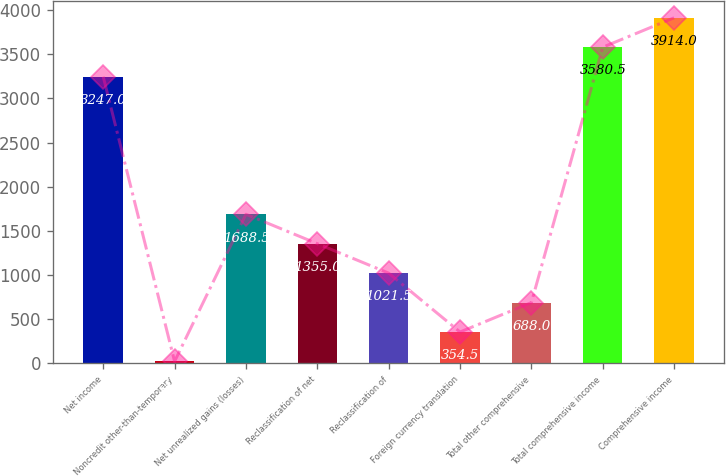Convert chart to OTSL. <chart><loc_0><loc_0><loc_500><loc_500><bar_chart><fcel>Net income<fcel>Noncredit other-than-temporary<fcel>Net unrealized gains (losses)<fcel>Reclassification of net<fcel>Reclassification of<fcel>Foreign currency translation<fcel>Total other comprehensive<fcel>Total comprehensive income<fcel>Comprehensive income<nl><fcel>3247<fcel>21<fcel>1688.5<fcel>1355<fcel>1021.5<fcel>354.5<fcel>688<fcel>3580.5<fcel>3914<nl></chart> 